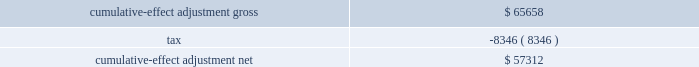Other-than-temporary impairments on investment securities .
In april 2009 , the fasb revised the authoritative guidance for the recognition and presentation of other-than-temporary impairments .
This new guidance amends the recognition guidance for other-than-temporary impairments of debt securities and expands the financial statement disclosures for other-than-temporary impairments on debt and equity securities .
For available for sale debt securities that the company has no intent to sell and more likely than not will not be required to sell prior to recovery , only the credit loss component of the impairment would be recognized in earnings , while the rest of the fair value loss would be recognized in accumulated other comprehensive income ( loss ) .
The company adopted this guidance effective april 1 , 2009 .
Upon adoption the company recognized a cumulative-effect adjustment increase in retained earnings ( deficit ) and decrease in accumulated other comprehensive income ( loss ) as follows : ( dollars in thousands ) .
Measurement of fair value in inactive markets .
In april 2009 , the fasb revised the authoritative guidance for fair value measurements and disclosures , which reaffirms that fair value is the price that would be received to sell an asset or paid to transfer a liability in an orderly transaction between market participants at the measurement date under current market conditions .
It also reaffirms the need to use judgment in determining if a formerly active market has become inactive and in determining fair values when the market has become inactive .
There was no impact to the company 2019s financial statements upon adoption .
Fair value disclosures about pension plan assets .
In december 2008 , the fasb revised the authoritative guidance for employers 2019 disclosures about pension plan assets .
This new guidance requires additional disclosures about the components of plan assets , investment strategies for plan assets and significant concentrations of risk within plan assets .
The company , in conjunction with fair value measurement of plan assets , separated plan assets into the three fair value hierarchy levels and provided a roll forward of the changes in fair value of plan assets classified as level 3 in the 2009 annual consolidated financial statements .
These disclosures had no effect on the company 2019s accounting for plan benefits and obligations .
Revisions to earnings per share calculation .
In june 2008 , the fasb revised the authoritative guidance for earnings per share for determining whether instruments granted in share-based payment transactions are participating securities .
This new guidance requires unvested share-based payment awards that contain non- forfeitable rights to dividends be considered as a separate class of common stock and included in the earnings per share calculation using the two-class method .
The company 2019s restricted share awards meet this definition and are therefore included in the basic earnings per share calculation .
Additional disclosures for derivative instruments .
In march 2008 , the fasb issued authoritative guidance for derivative instruments and hedging activities , which requires enhanced disclosures on derivative instruments and hedged items .
On january 1 , 2009 , the company adopted the additional disclosure for the equity index put options .
No comparative information for periods prior to the effective date was required .
This guidance had no impact on how the company records its derivatives. .
Following the adoption of the new guidence on the other-than-temporary impairments on investment securities what was the tax rate on the gross cumulative-effect adjustment? 
Computations: (8346 / 65658)
Answer: 0.12711. 